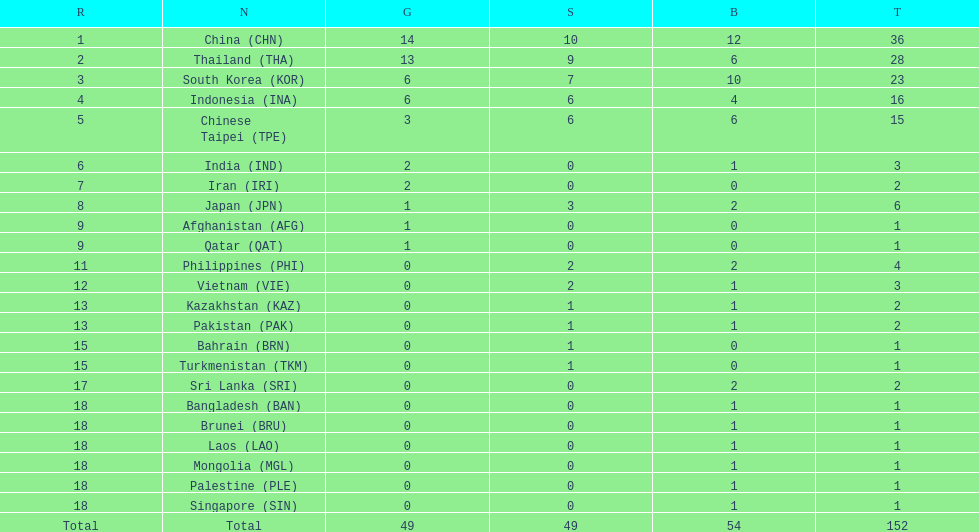How many nations received more than 5 gold medals? 4. 